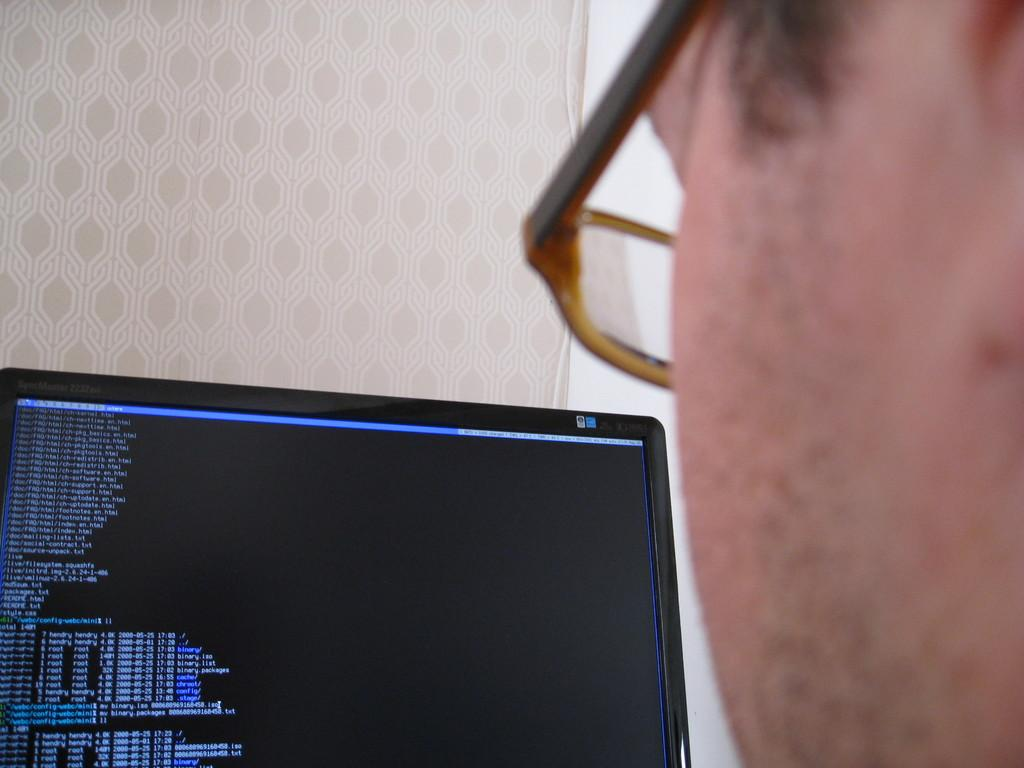Who is present in the image? There is a person in the image. What can be observed about the person's appearance? The person is wearing spectacles. What is the person's location in the image? The person is in front of a screen. What is visible on the screen? Something is displayed on the screen. How many lawyers are present in the image? There is no mention of lawyers in the image, so we cannot determine their presence. What color are the person's eyes in the image? The person's eyes are not visible in the image, so we cannot determine their color. 